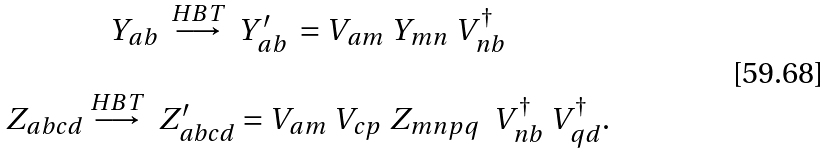<formula> <loc_0><loc_0><loc_500><loc_500>\begin{array} { c } Y _ { a b } \ \overset { H B T } { \longrightarrow } \ Y _ { a b } ^ { \prime } \ = V _ { a m } \ Y _ { m n } \ V ^ { \dagger } _ { n b } \ \\ \\ Z _ { a b c d } \overset { H B T } { \longrightarrow } \ Z _ { a b c d } ^ { \prime } = V _ { a m } \ V _ { c p } \ Z _ { m n p q } \ \ V ^ { \dagger } _ { n b } \ V ^ { \dagger } _ { q d } . \ \end{array}</formula> 